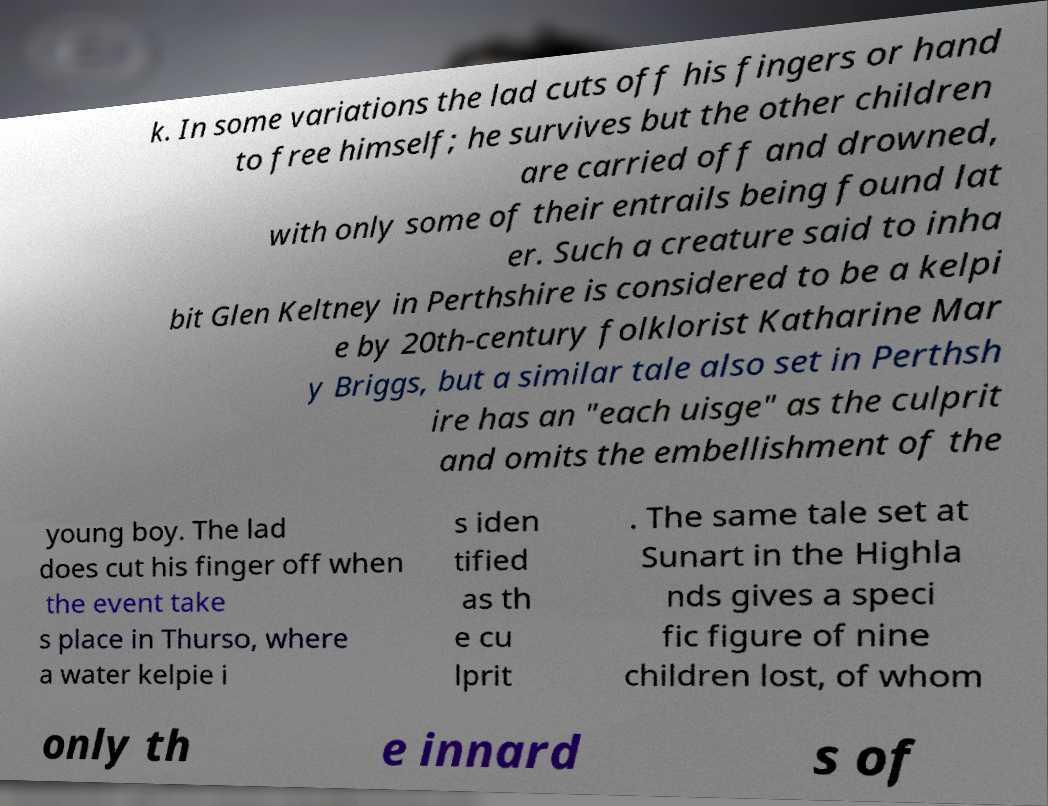I need the written content from this picture converted into text. Can you do that? k. In some variations the lad cuts off his fingers or hand to free himself; he survives but the other children are carried off and drowned, with only some of their entrails being found lat er. Such a creature said to inha bit Glen Keltney in Perthshire is considered to be a kelpi e by 20th-century folklorist Katharine Mar y Briggs, but a similar tale also set in Perthsh ire has an "each uisge" as the culprit and omits the embellishment of the young boy. The lad does cut his finger off when the event take s place in Thurso, where a water kelpie i s iden tified as th e cu lprit . The same tale set at Sunart in the Highla nds gives a speci fic figure of nine children lost, of whom only th e innard s of 